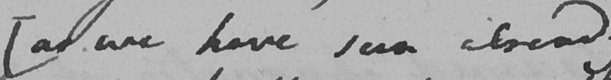Please transcribe the handwritten text in this image. [ as we have seen already ) 